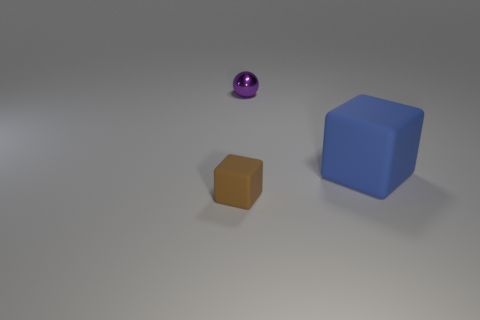Do the object in front of the big blue matte cube and the tiny metallic thing have the same shape?
Provide a short and direct response. No. How many metallic balls are the same size as the brown cube?
Provide a short and direct response. 1. How many spheres are behind the rubber object that is in front of the large blue block?
Offer a terse response. 1. Do the small object that is in front of the purple metallic object and the tiny purple object have the same material?
Offer a very short reply. No. Are the small object that is behind the large blue matte cube and the block that is to the left of the tiny metallic ball made of the same material?
Make the answer very short. No. Are there more tiny rubber blocks in front of the small brown thing than small red matte cylinders?
Your response must be concise. No. The object that is in front of the matte object behind the tiny brown block is what color?
Make the answer very short. Brown. There is a purple metallic object that is the same size as the brown matte cube; what shape is it?
Keep it short and to the point. Sphere. Are there an equal number of small shiny balls in front of the small brown block and small red objects?
Keep it short and to the point. Yes. There is a thing in front of the thing on the right side of the metal ball that is behind the blue rubber thing; what is its material?
Ensure brevity in your answer.  Rubber. 